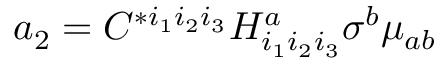Convert formula to latex. <formula><loc_0><loc_0><loc_500><loc_500>a _ { 2 } = C ^ { * i _ { 1 } i _ { 2 } i _ { 3 } } H _ { i _ { 1 } i _ { 2 } i _ { 3 } } ^ { a } \sigma ^ { b } \mu _ { a b }</formula> 